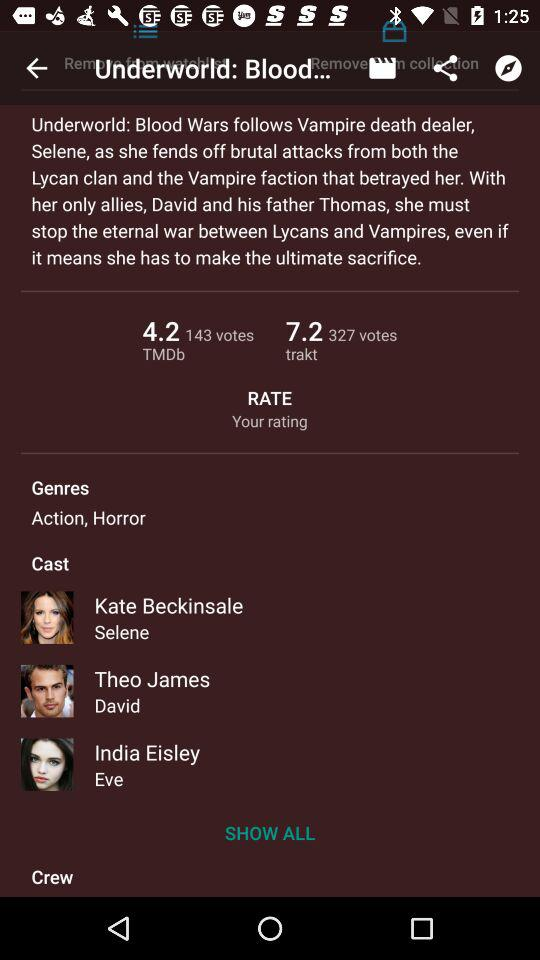What is the TMDb score? The score is 4.2. 